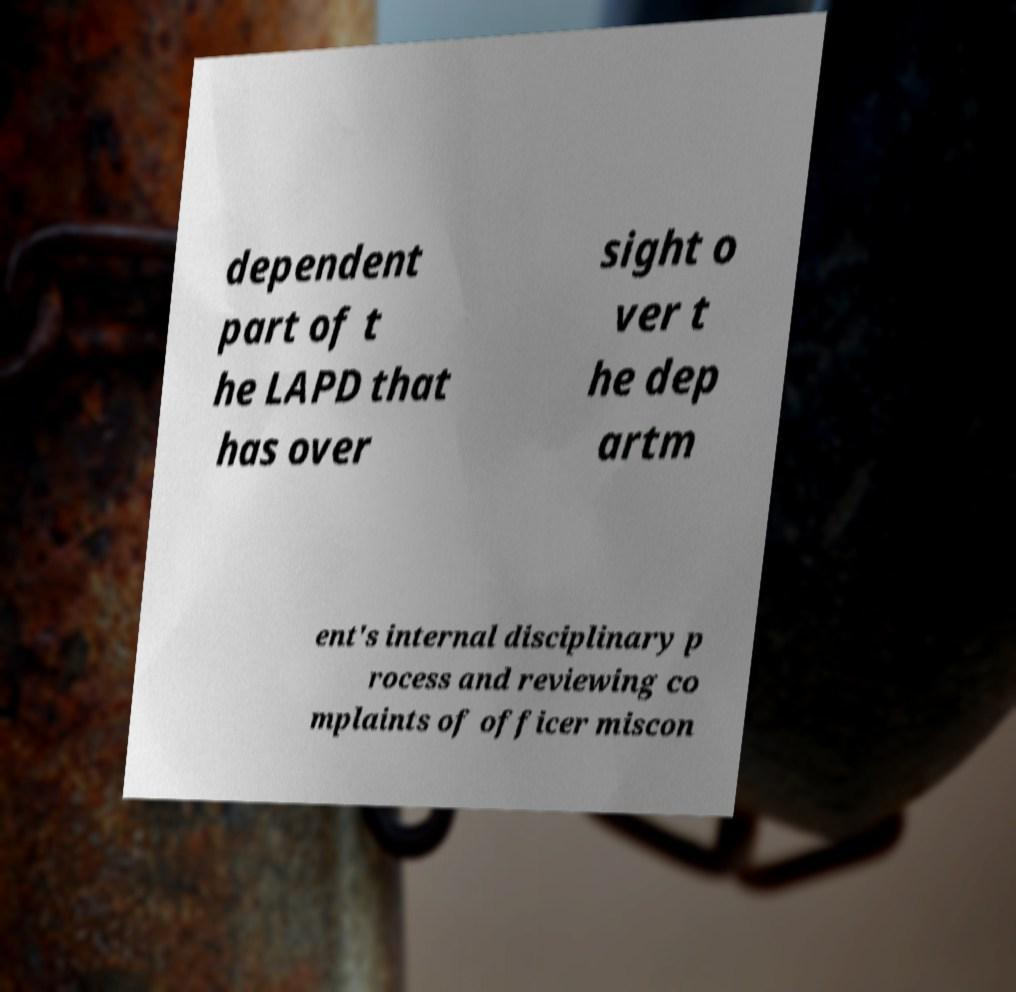What messages or text are displayed in this image? I need them in a readable, typed format. dependent part of t he LAPD that has over sight o ver t he dep artm ent's internal disciplinary p rocess and reviewing co mplaints of officer miscon 